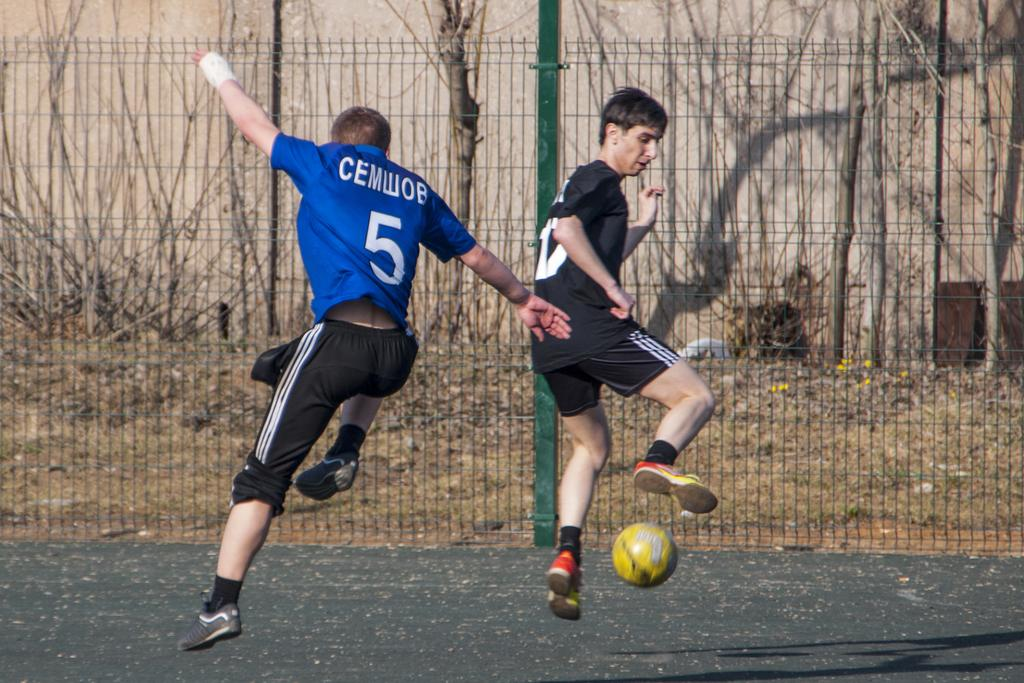Provide a one-sentence caption for the provided image. Number 5 attempts to steal the ball away from the other player in black. 